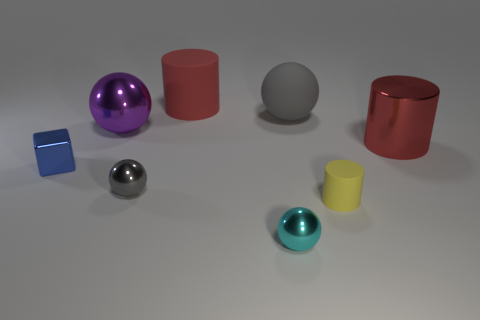What size is the purple object?
Your answer should be compact. Large. How many gray objects are big metallic balls or cylinders?
Your answer should be compact. 0. What is the size of the cylinder that is behind the shiny ball behind the small metallic block?
Offer a terse response. Large. There is a big rubber sphere; is it the same color as the small metallic sphere that is behind the yellow cylinder?
Provide a succinct answer. Yes. How many other things are there of the same material as the tiny cylinder?
Your response must be concise. 2. What is the shape of the red thing that is made of the same material as the small yellow cylinder?
Your answer should be compact. Cylinder. Are there any other things of the same color as the shiny cube?
Your response must be concise. No. The object that is the same color as the rubber ball is what size?
Provide a succinct answer. Small. Is the number of tiny spheres in front of the small rubber cylinder greater than the number of big cyan matte spheres?
Ensure brevity in your answer.  Yes. Does the gray rubber thing have the same shape as the small metal thing to the left of the purple object?
Provide a short and direct response. No. 